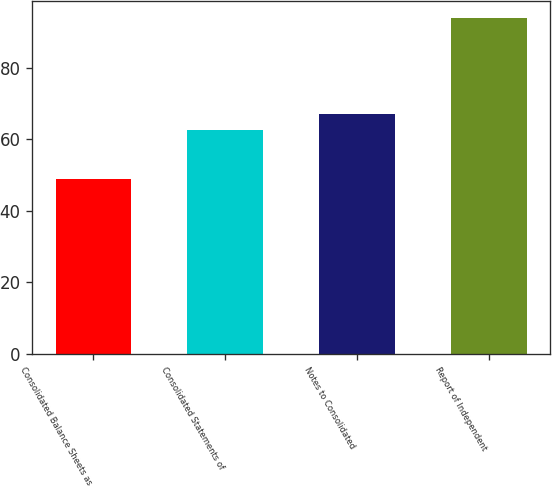<chart> <loc_0><loc_0><loc_500><loc_500><bar_chart><fcel>Consolidated Balance Sheets as<fcel>Consolidated Statements of<fcel>Notes to Consolidated<fcel>Report of Independent<nl><fcel>49<fcel>62.5<fcel>67<fcel>94<nl></chart> 